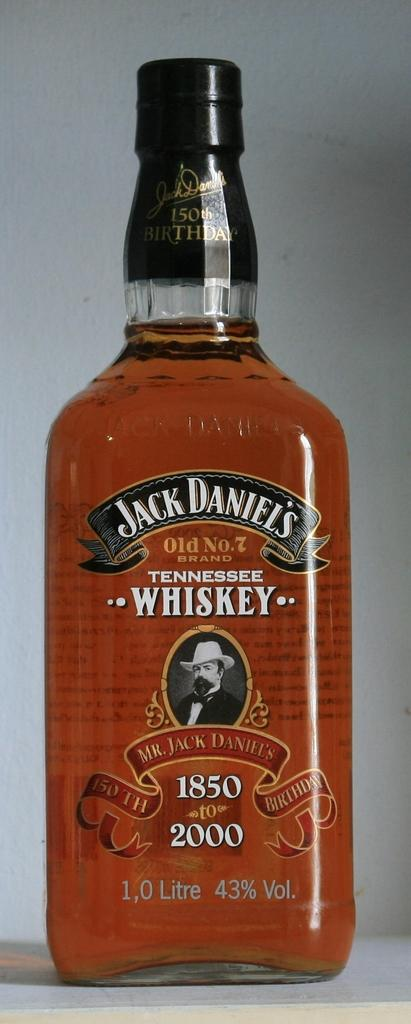<image>
Render a clear and concise summary of the photo. A bottle of Jack Daniel's Tennesee Whiskey sits on a table. 